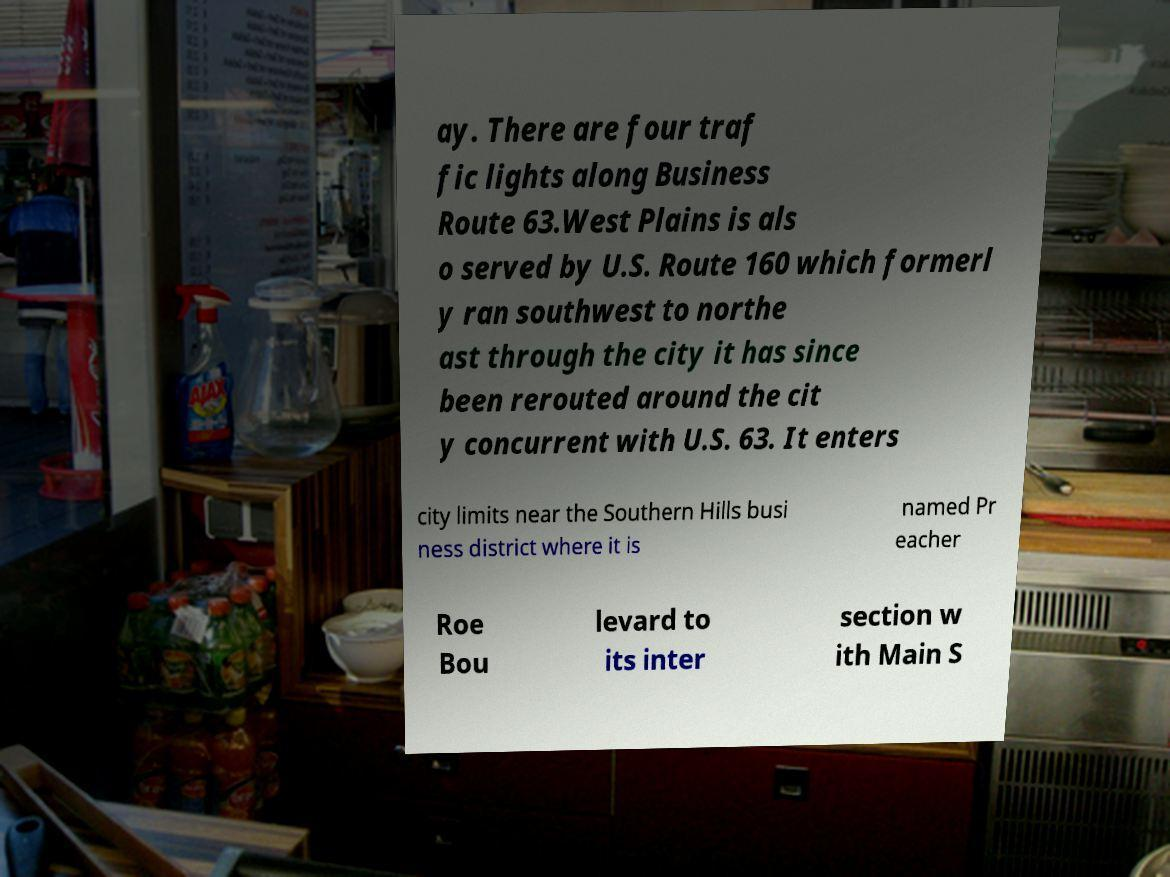There's text embedded in this image that I need extracted. Can you transcribe it verbatim? ay. There are four traf fic lights along Business Route 63.West Plains is als o served by U.S. Route 160 which formerl y ran southwest to northe ast through the city it has since been rerouted around the cit y concurrent with U.S. 63. It enters city limits near the Southern Hills busi ness district where it is named Pr eacher Roe Bou levard to its inter section w ith Main S 